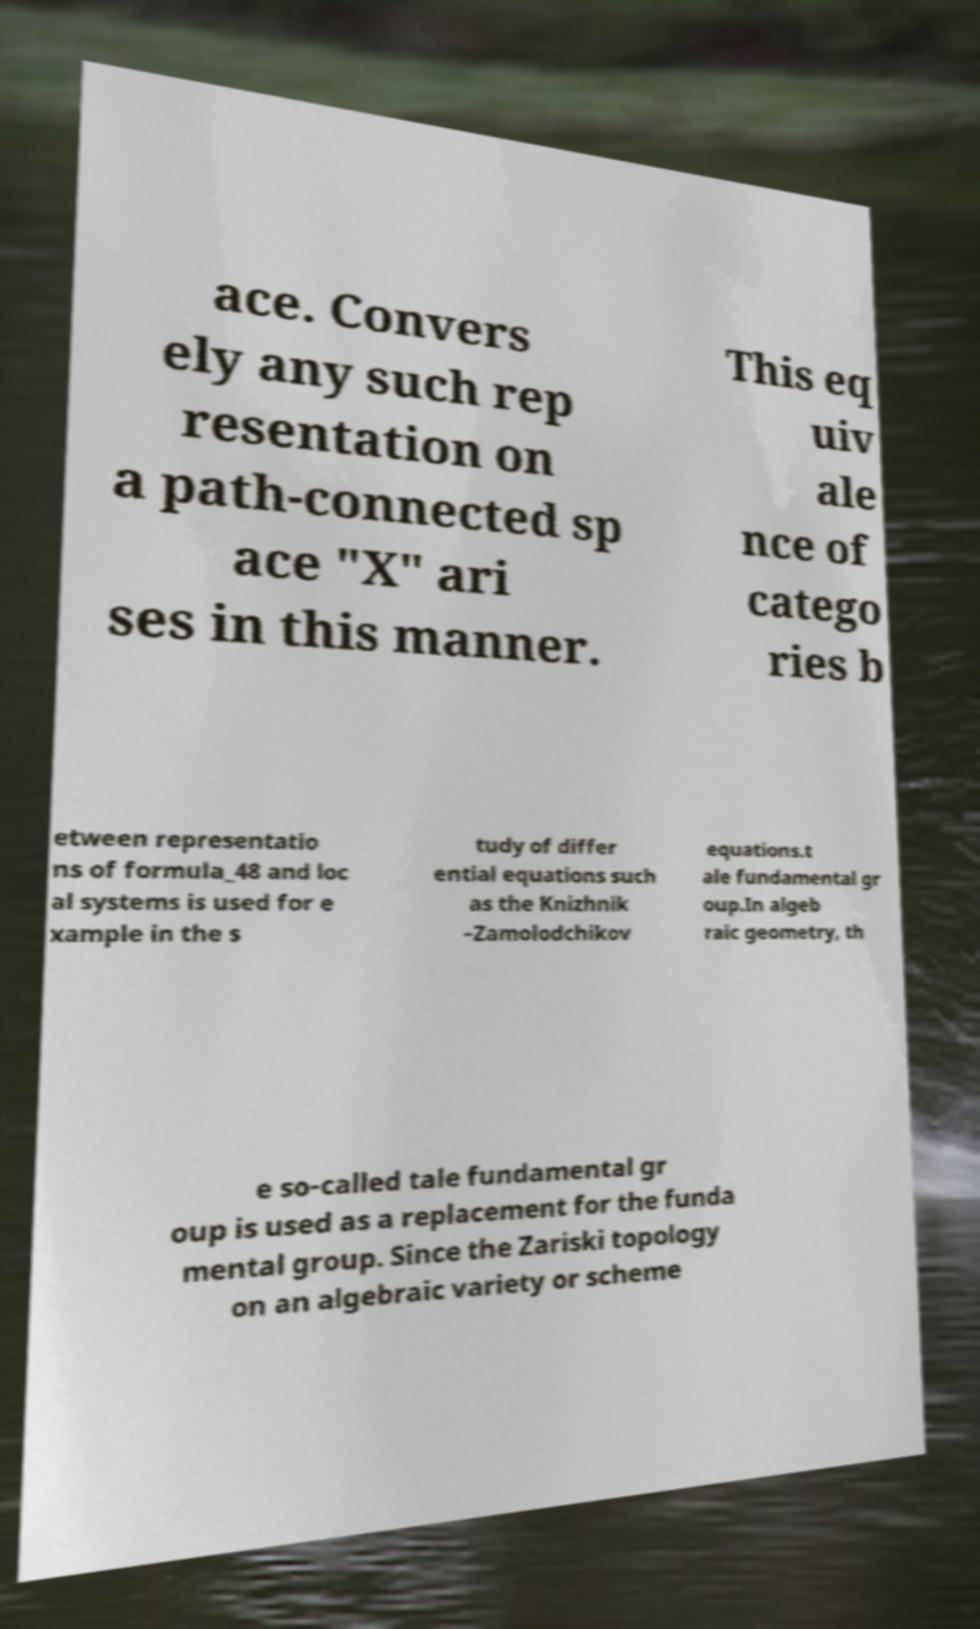Could you assist in decoding the text presented in this image and type it out clearly? ace. Convers ely any such rep resentation on a path-connected sp ace "X" ari ses in this manner. This eq uiv ale nce of catego ries b etween representatio ns of formula_48 and loc al systems is used for e xample in the s tudy of differ ential equations such as the Knizhnik –Zamolodchikov equations.t ale fundamental gr oup.In algeb raic geometry, th e so-called tale fundamental gr oup is used as a replacement for the funda mental group. Since the Zariski topology on an algebraic variety or scheme 